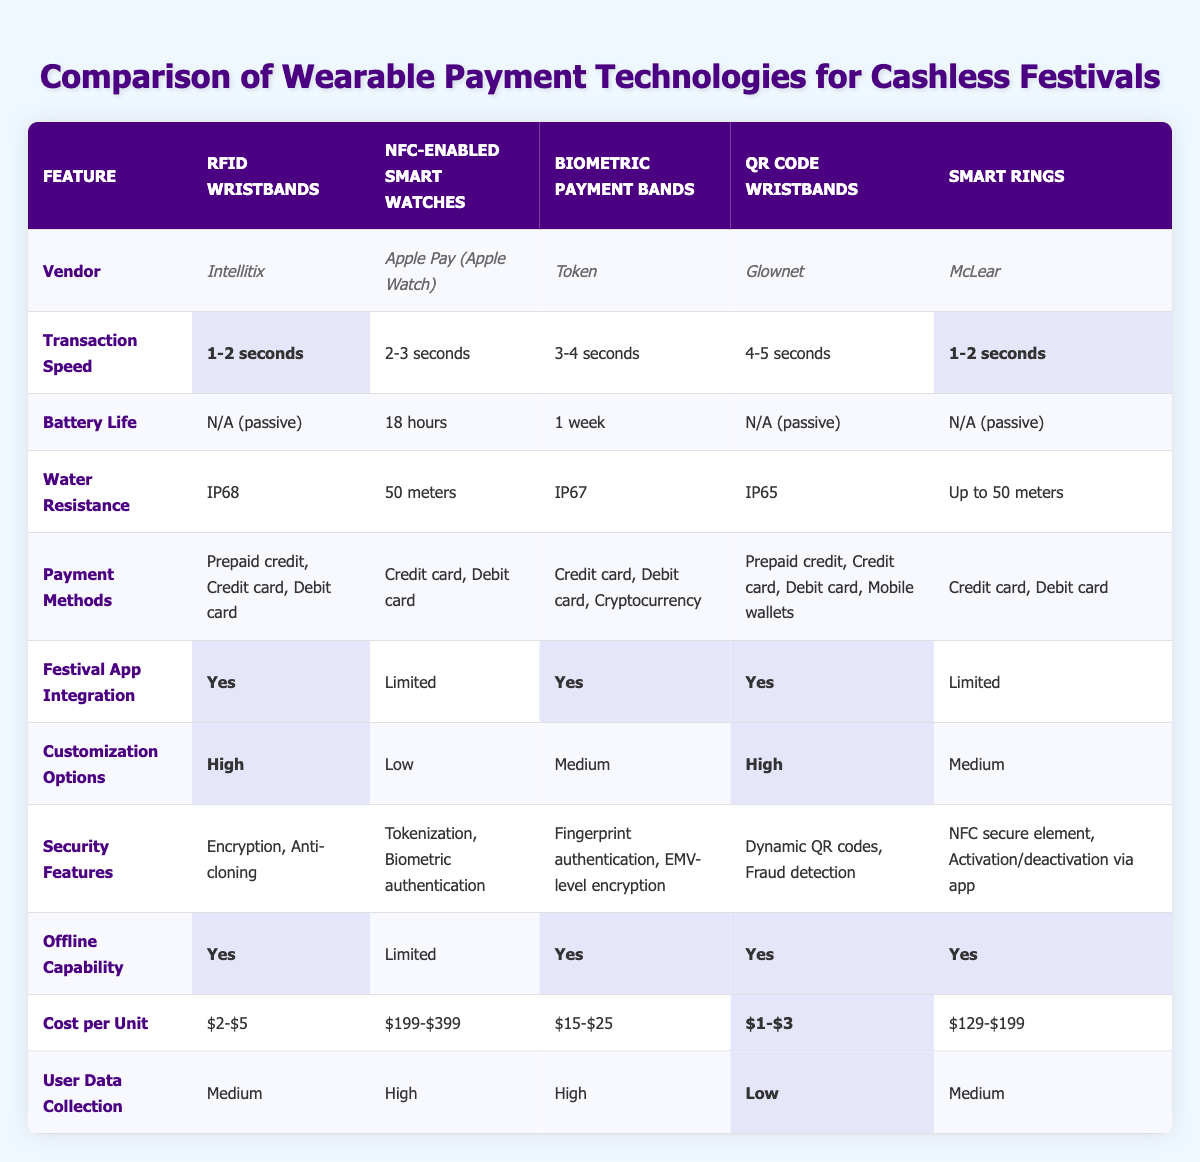What is the transaction speed of RFID Wristbands? The table shows that the transaction speed of RFID Wristbands is listed as "1-2 seconds." This is a direct retrieval of information from the corresponding cell in the table.
Answer: 1-2 seconds Which payment methods are supported by QR Code Wristbands? By referring to the row for QR Code Wristbands, it indicates that the supported payment methods are "Prepaid credit, Credit card, Debit card, Mobile wallets." This is a specific retrieval of facts from the table.
Answer: Prepaid credit, Credit card, Debit card, Mobile wallets Do Biometric Payment Bands have offline capability? The entry for Biometric Payment Bands shows "Yes" under offline capability, indicating that this payment technology does allow for offline transactions. This is a factual question that can be answered directly from the table.
Answer: Yes What is the average cost per unit of the wearable payment technologies? To find the average cost per unit, we first identify the cost ranges: RFID Wristbands ($2-$5), NFC-enabled Smart Watches ($199-$399), Biometric Payment Bands ($15-$25), QR Code Wristbands ($1-$3), and Smart Rings ($129-$199). To calculate the average cost, we can use the midpoints of the ranges: (3.5 + 299 + 20 + 2 + 164)/5 = 97.5.
Answer: 97.5 Which wearable payment technology has the longest battery life? The battery life of the wearable payment technologies varies: RFID Wristbands (N/A), NFC-enabled Smart Watches (18 hours), Biometric Payment Bands (1 week), QR Code Wristbands (N/A), and Smart Rings (N/A). Given that 1 week is longer than 18 hours, we see that the Biometric Payment Bands have the longest battery life. This requires reasoning by comparing the durations stated in the table.
Answer: Biometric Payment Bands Are all wearable payment technologies water-resistant? Reviewing the water resistance column reveals that RFID Wristbands (IP68), NFC-enabled Smart Watches (50 meters), Biometric Payment Bands (IP67), QR Code Wristbands (IP65), and Smart Rings (Up to 50 meters) are all water-resistant to varying degrees. Therefore, to answer this, we conclude that they are all indeed water-resistant.
Answer: Yes Which vendor has the high customization options? The table lists customization options for the different technologies: RFID Wristbands (High), NFC-enabled Smart Watches (Low), Biometric Payment Bands (Medium), QR Code Wristbands (High), and Smart Rings (Medium). The vendors for RFID Wristbands and QR Code Wristbands both have high customization options. So, the answer focuses on the vendors related to high customization features.
Answer: Intellitix, Glownet Is the user data collection level for Smart Rings considered high? Checking the user data collection column, Smart Rings are noted as having "Medium." Thus, this question represents a direct retrieval of information while confirming the level isn't categorized as high.
Answer: No 